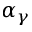Convert formula to latex. <formula><loc_0><loc_0><loc_500><loc_500>\alpha _ { \gamma }</formula> 